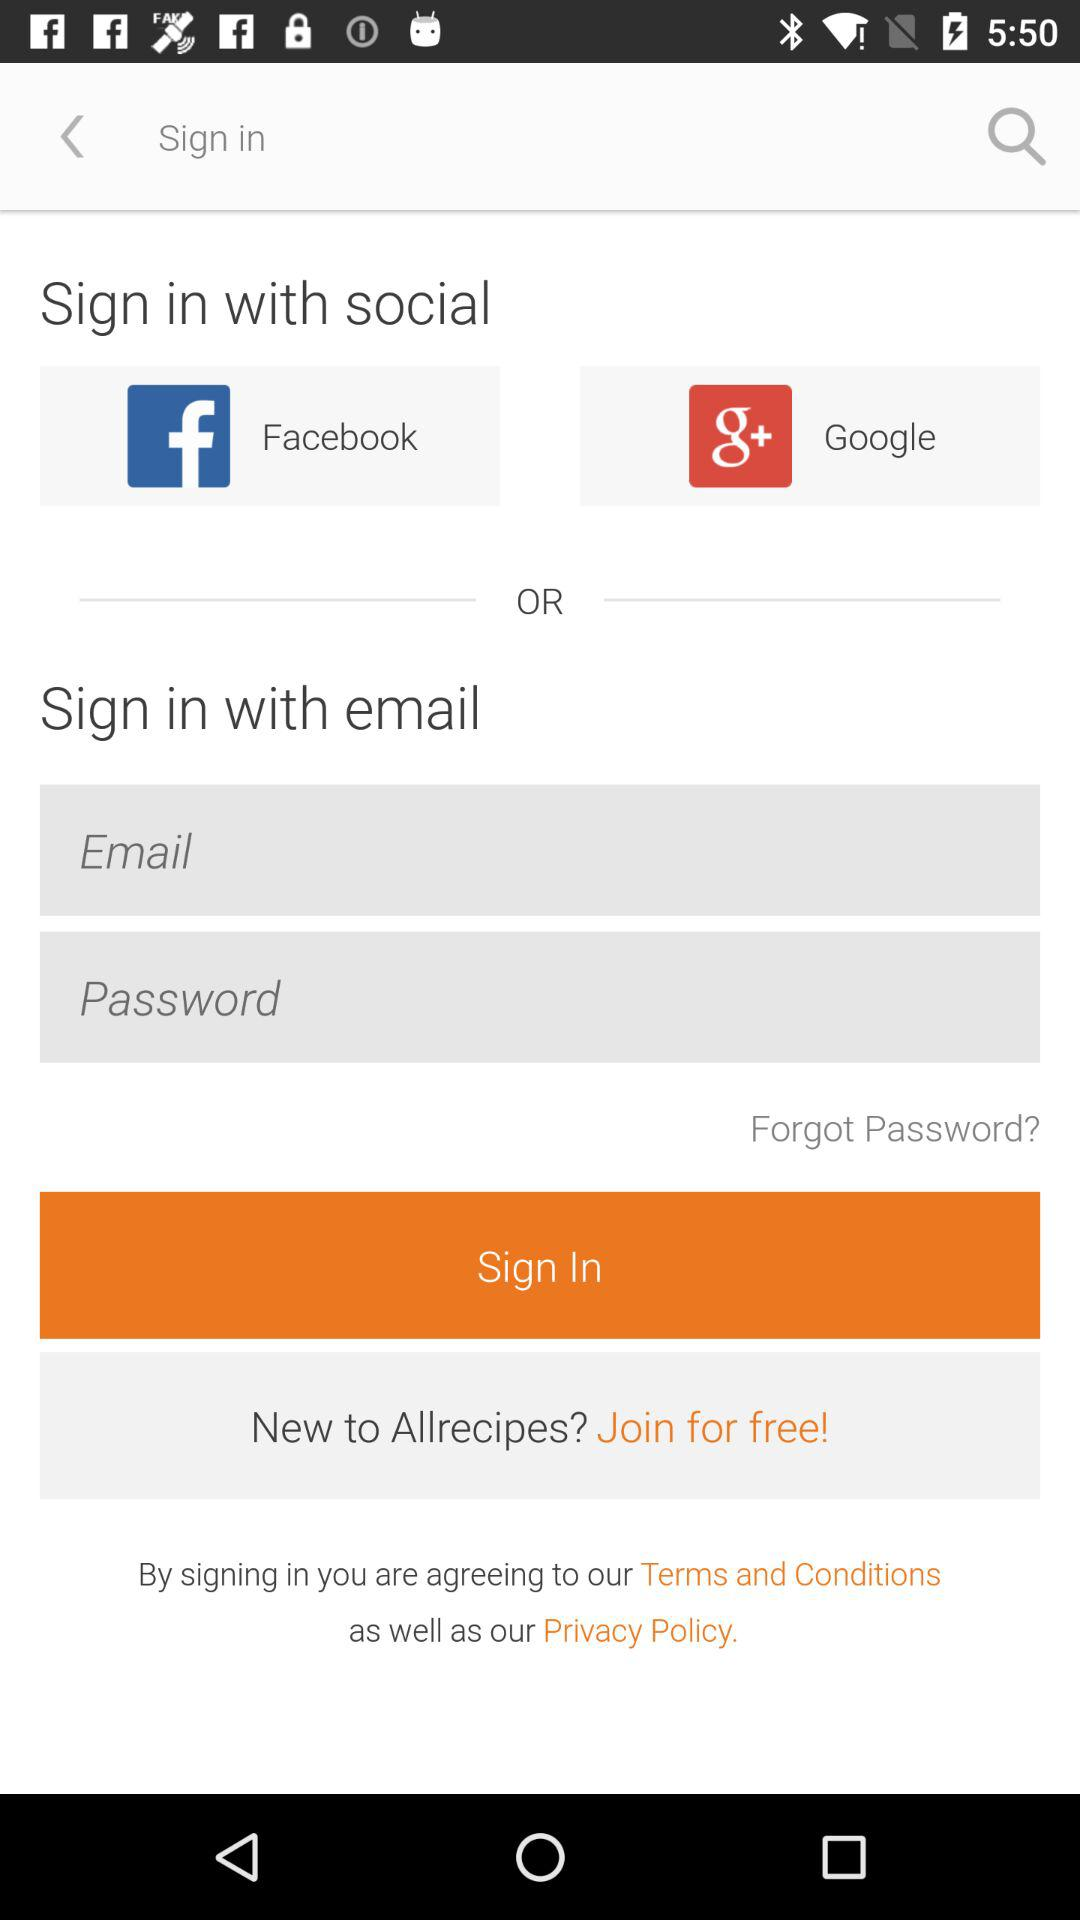How many fields must I fill out to sign in with email?
Answer the question using a single word or phrase. 2 